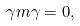Convert formula to latex. <formula><loc_0><loc_0><loc_500><loc_500>\gamma m \gamma = 0 ,</formula> 